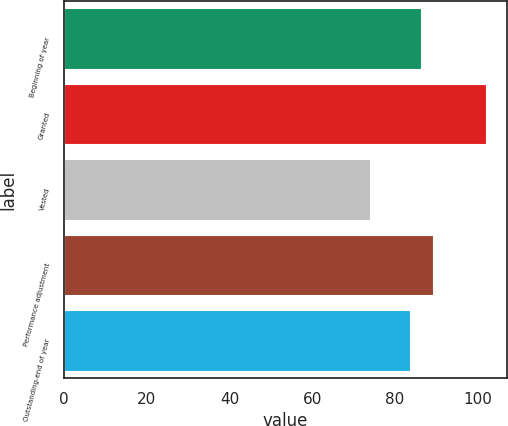Convert chart to OTSL. <chart><loc_0><loc_0><loc_500><loc_500><bar_chart><fcel>Beginning of year<fcel>Granted<fcel>Vested<fcel>Performance adjustment<fcel>Outstanding-end of year<nl><fcel>86.34<fcel>101.9<fcel>74.02<fcel>89.13<fcel>83.55<nl></chart> 